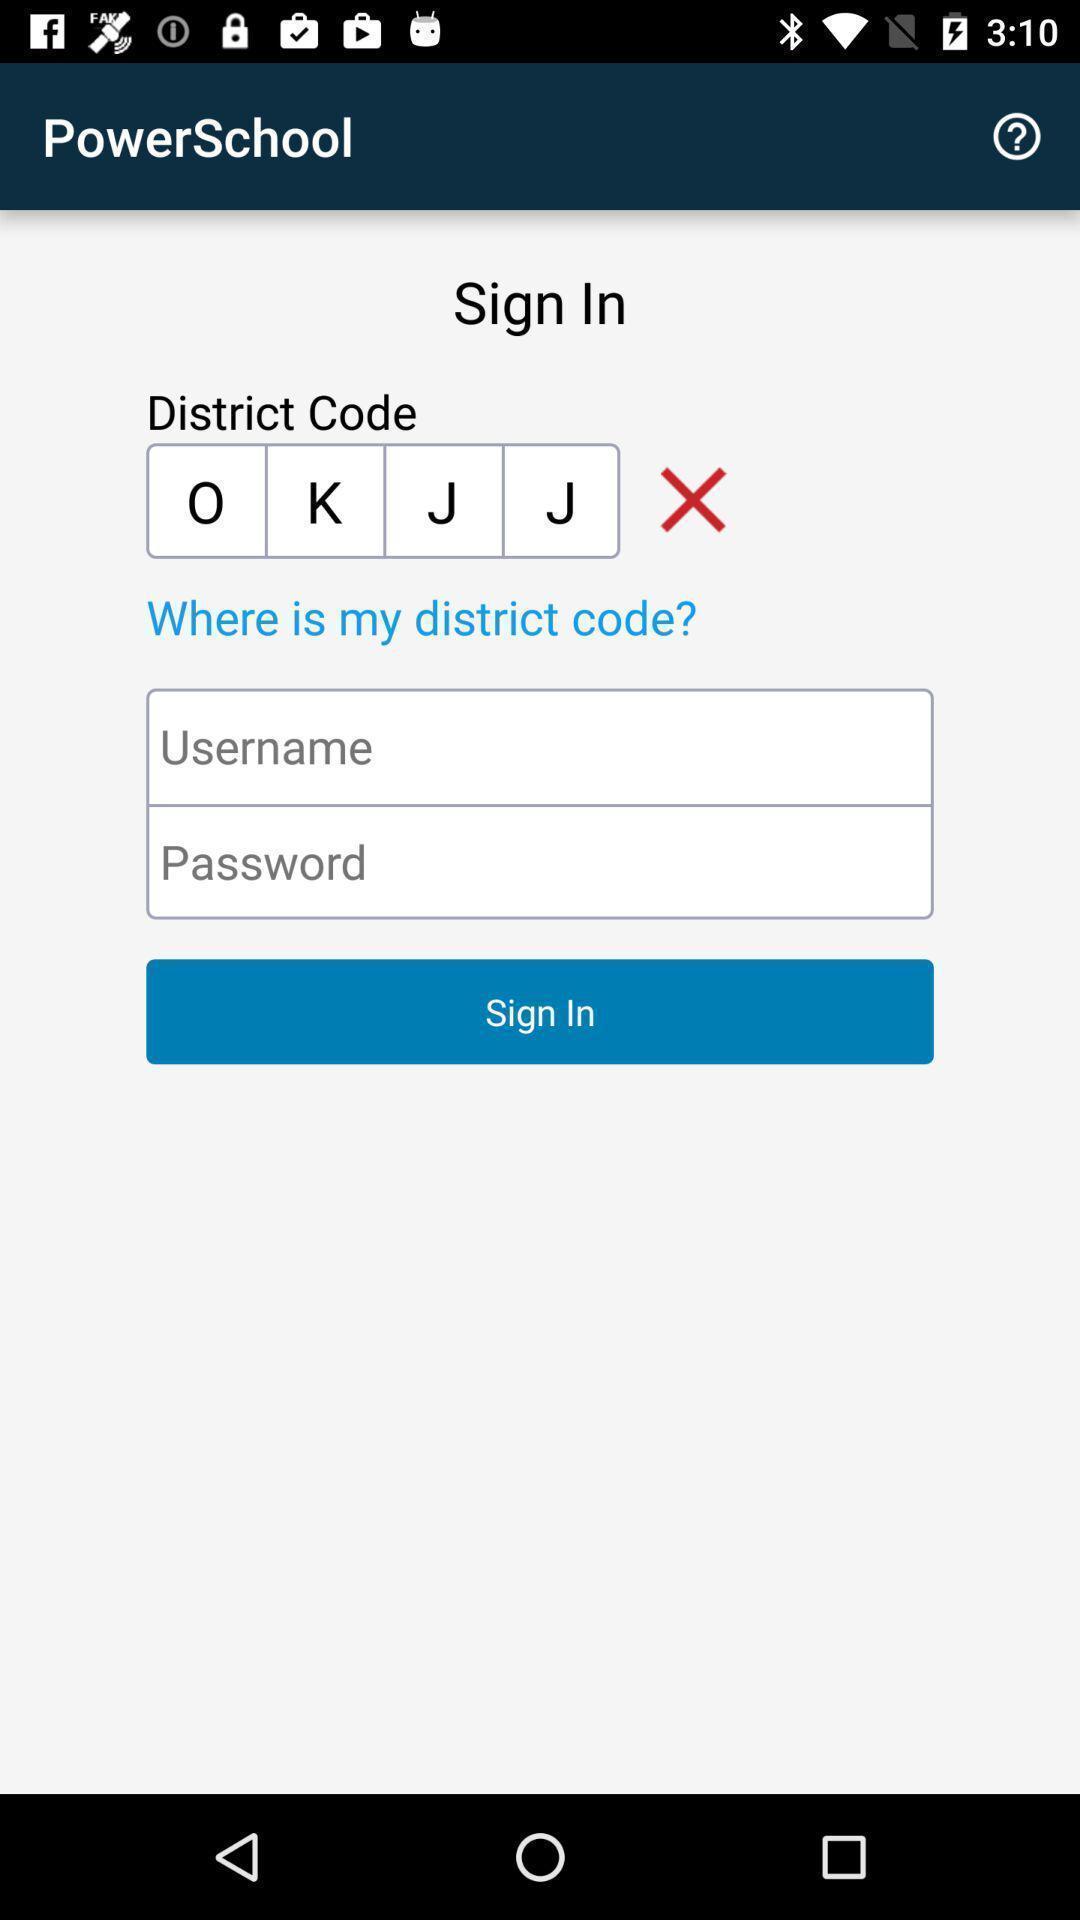Explain the elements present in this screenshot. Sign in page. 